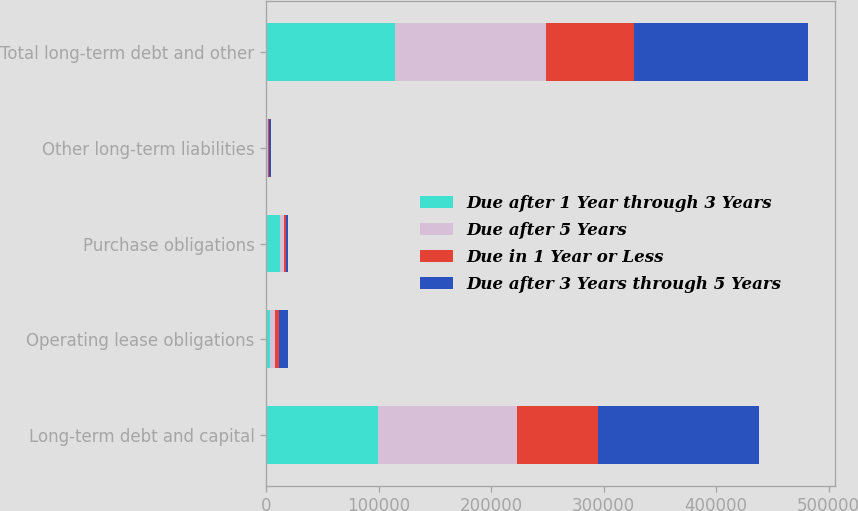Convert chart to OTSL. <chart><loc_0><loc_0><loc_500><loc_500><stacked_bar_chart><ecel><fcel>Long-term debt and capital<fcel>Operating lease obligations<fcel>Purchase obligations<fcel>Other long-term liabilities<fcel>Total long-term debt and other<nl><fcel>Due after 1 Year through 3 Years<fcel>99144<fcel>3143<fcel>11957<fcel>610<fcel>114854<nl><fcel>Due after 5 Years<fcel>124054<fcel>5072<fcel>3667<fcel>1097<fcel>133890<nl><fcel>Due in 1 Year or Less<fcel>72103<fcel>3355<fcel>1627<fcel>848<fcel>77933<nl><fcel>Due after 3 Years through 5 Years<fcel>143220<fcel>8143<fcel>2119<fcel>1464<fcel>154946<nl></chart> 